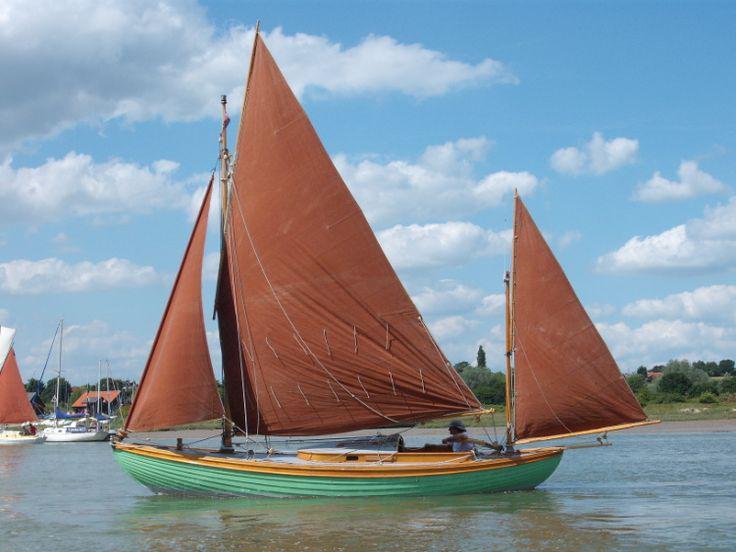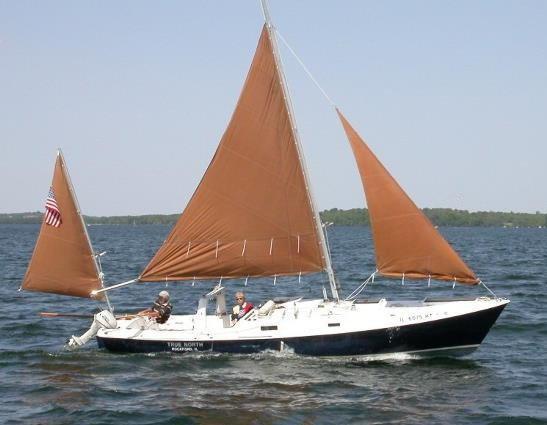The first image is the image on the left, the second image is the image on the right. Examine the images to the left and right. Is the description "One image shows a boat with a green exterior and brown sails." accurate? Answer yes or no. Yes. The first image is the image on the left, the second image is the image on the right. Analyze the images presented: Is the assertion "In one of the images there is a green and brown boat with brown sails" valid? Answer yes or no. Yes. The first image is the image on the left, the second image is the image on the right. For the images shown, is this caption "In one of the images the boat is blue." true? Answer yes or no. Yes. 